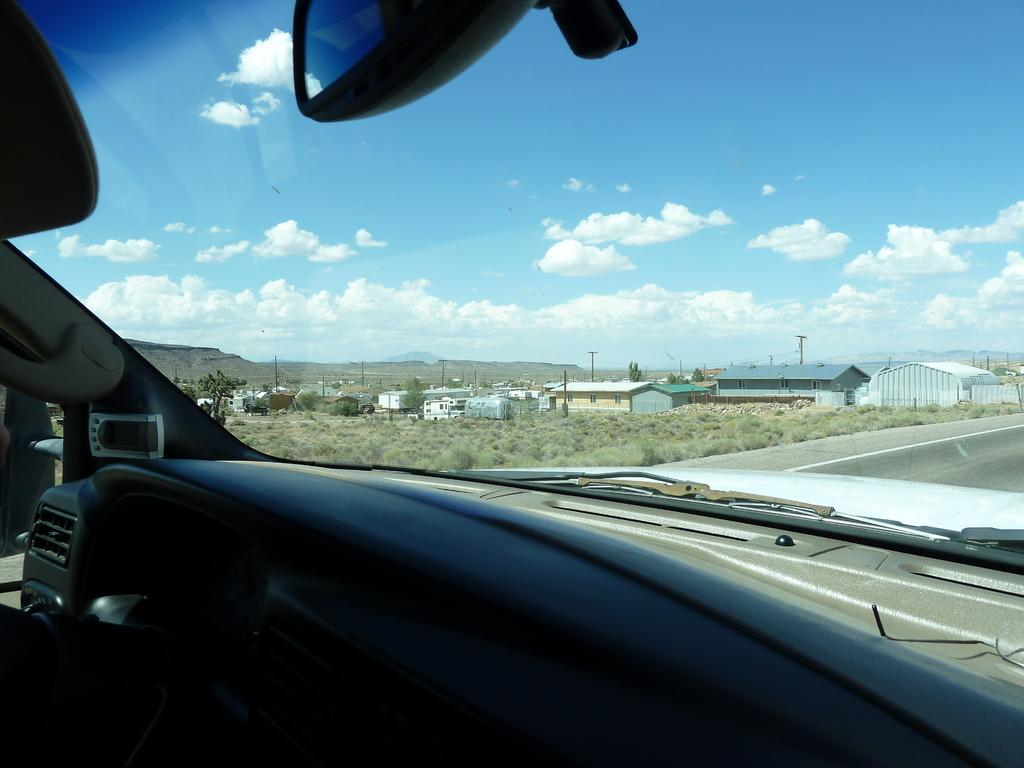What type of setting is shown in the image? The image shows an inside view of a vehicle. What can be seen in the background of the image? There is a road, an open grass ground, multiple buildings, poles, and trees visible in the background. What is visible in the sky in the image? Clouds are present in the sky, and the sky is visible in the background. What type of music can be heard playing from the swing in the image? There is no swing or music present in the image; it shows an inside view of a vehicle with a background of roads, grass, buildings, poles, trees, and sky. 